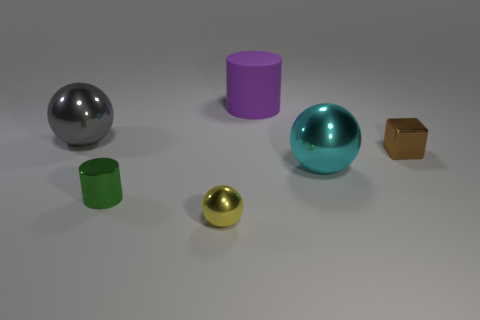Are there any large gray matte blocks?
Offer a terse response. No. There is a thing that is both on the right side of the yellow object and behind the small block; what material is it?
Ensure brevity in your answer.  Rubber. Is the number of small metal things in front of the large cyan ball greater than the number of tiny cubes on the left side of the tiny metal cube?
Keep it short and to the point. Yes. Are there any spheres that have the same size as the purple cylinder?
Provide a succinct answer. Yes. What is the size of the cylinder that is to the left of the cylinder that is behind the large metal sphere on the left side of the shiny cylinder?
Your answer should be compact. Small. What color is the tiny sphere?
Your response must be concise. Yellow. Is the number of small objects that are on the right side of the tiny metal cylinder greater than the number of small purple rubber cylinders?
Offer a terse response. Yes. How many large metallic balls are on the left side of the small brown metallic cube?
Your answer should be very brief. 2. There is a large shiny object that is on the right side of the large metallic thing that is on the left side of the rubber object; are there any big cyan objects that are in front of it?
Your response must be concise. No. Do the green metallic cylinder and the shiny cube have the same size?
Your answer should be very brief. Yes. 